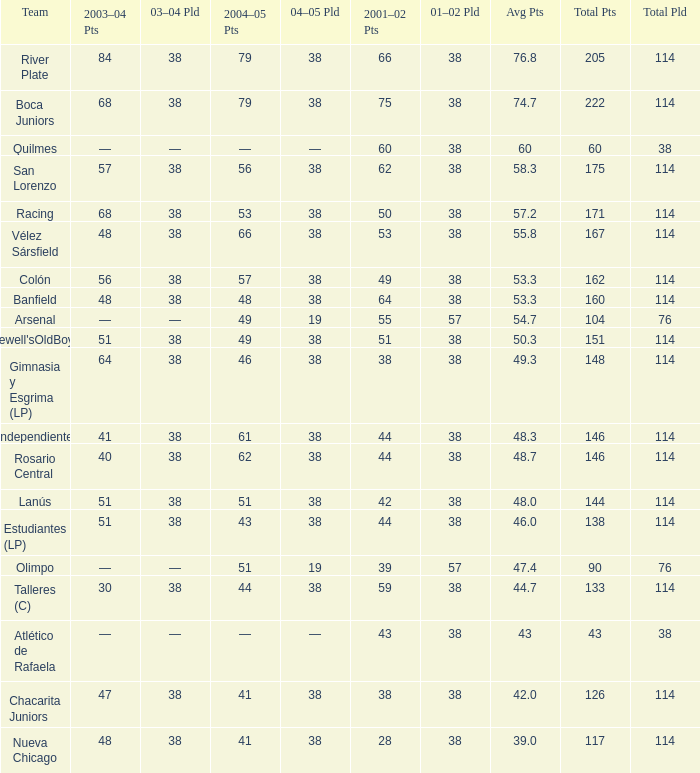Which Total Pts have a 2001–02 Pts smaller than 38? 117.0. 